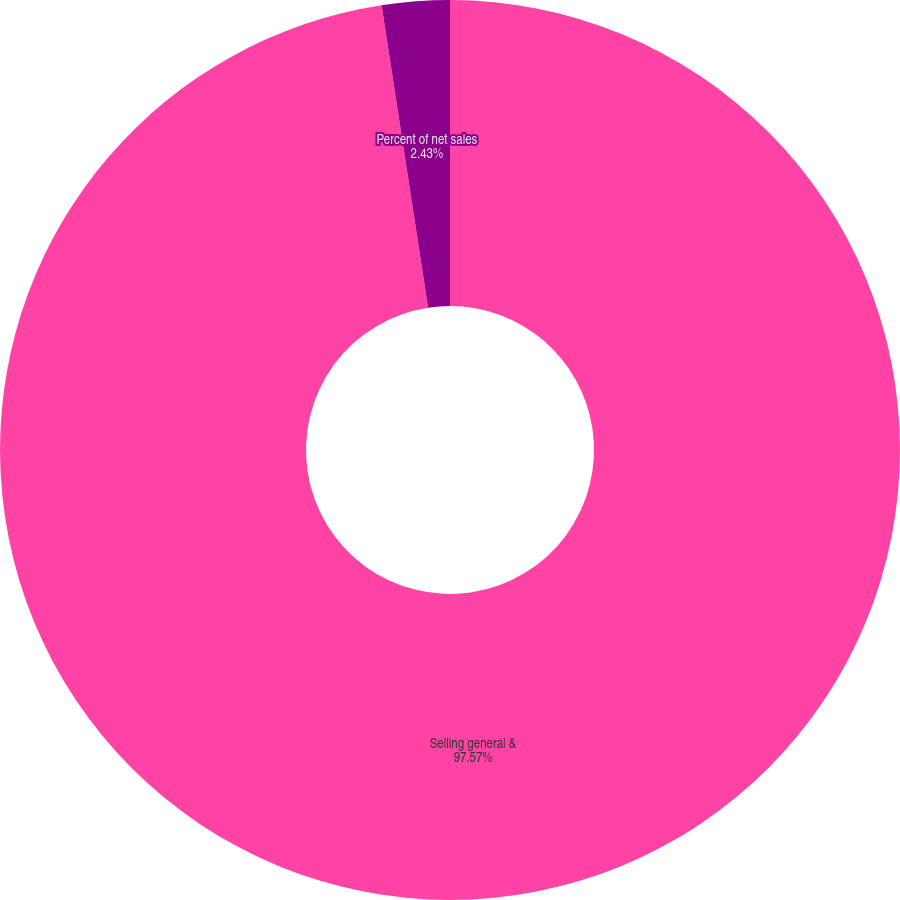Convert chart. <chart><loc_0><loc_0><loc_500><loc_500><pie_chart><fcel>Selling general &<fcel>Percent of net sales<nl><fcel>97.57%<fcel>2.43%<nl></chart> 